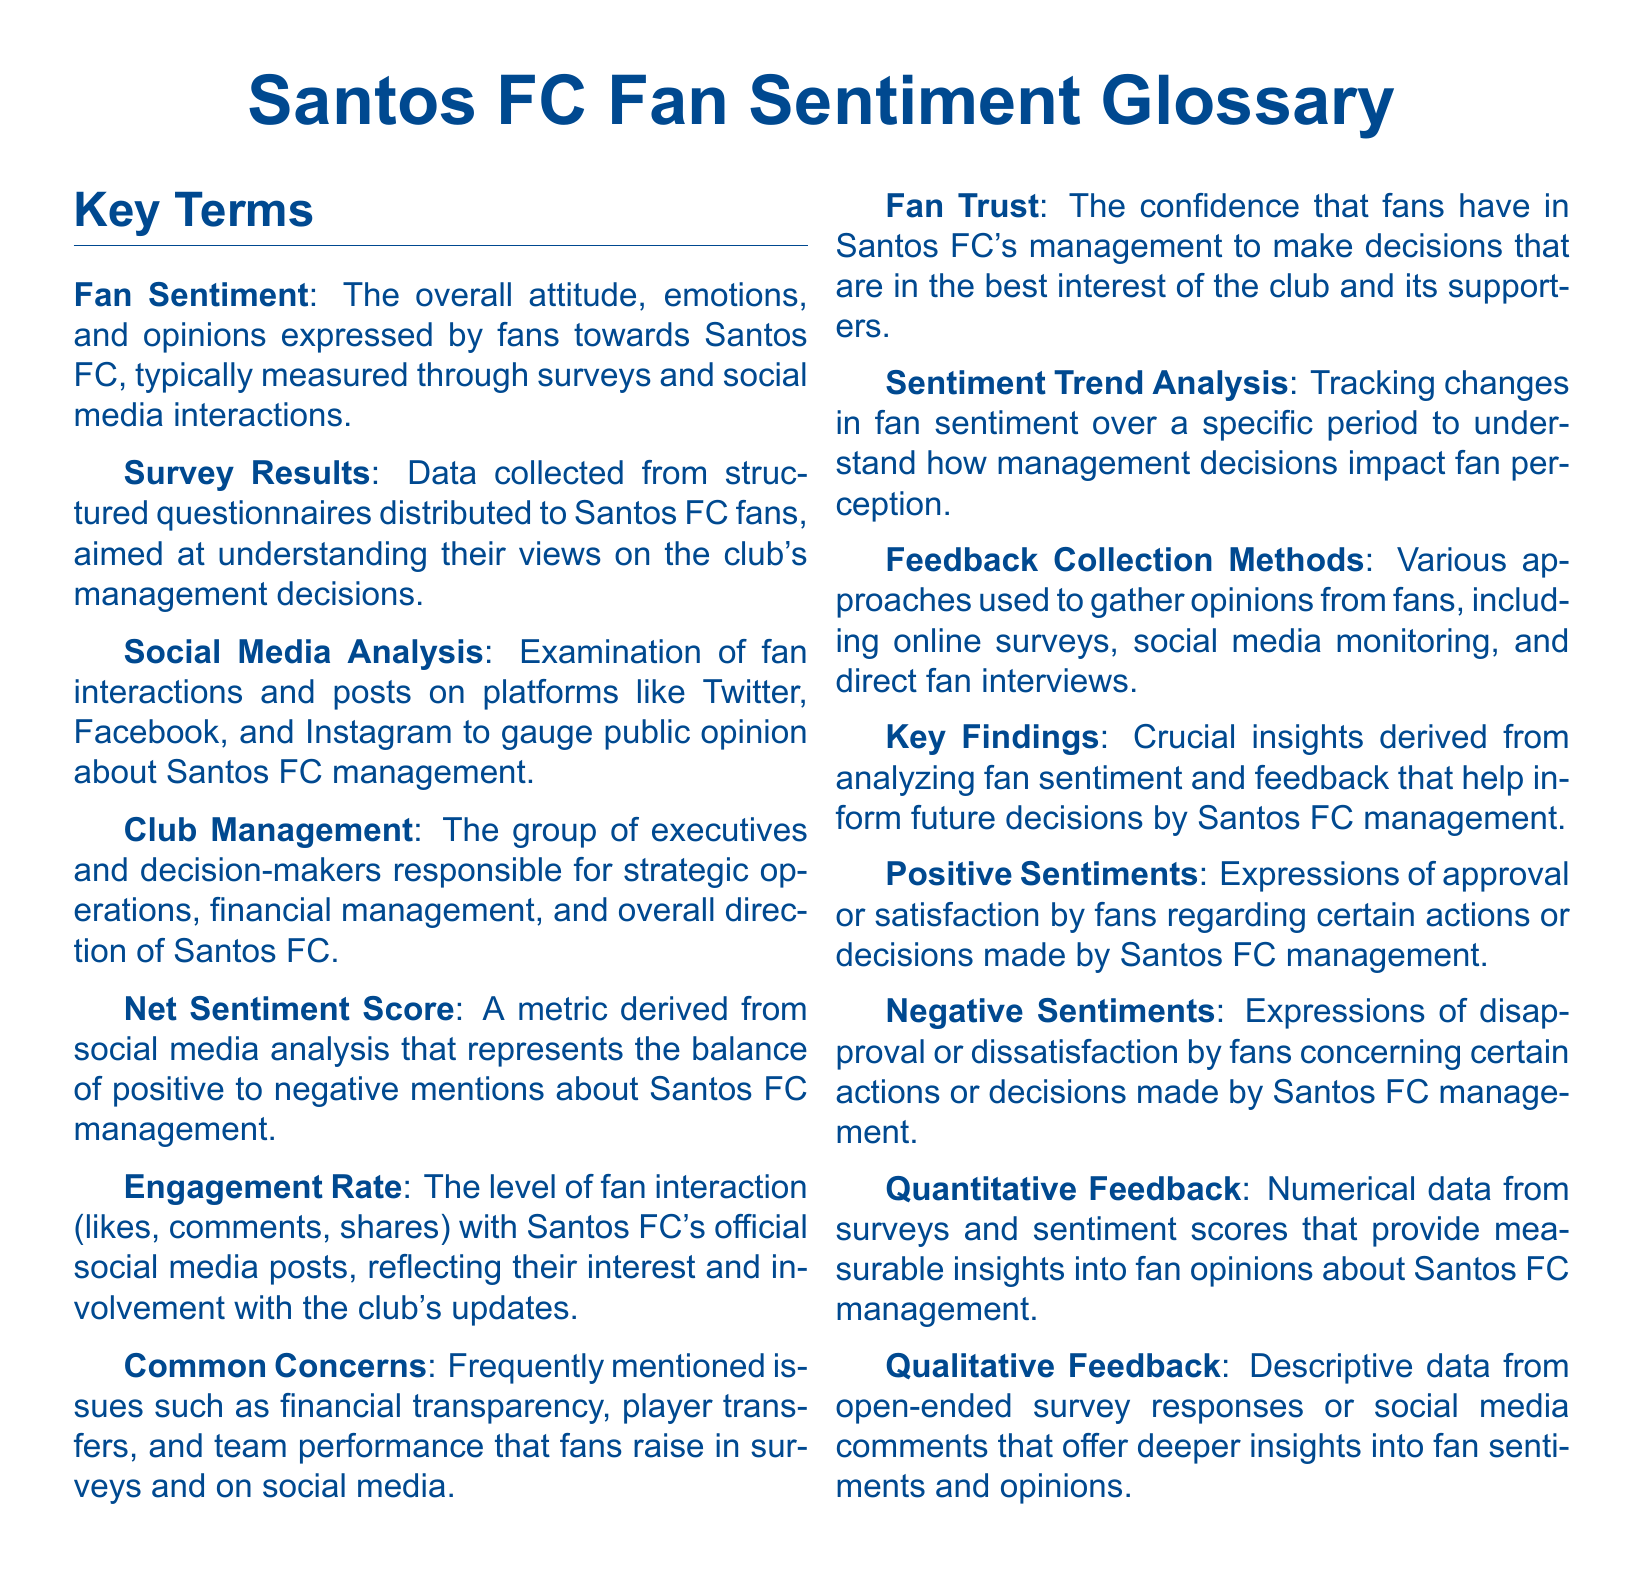what does fan sentiment mean? Fan sentiment refers to the overall attitude, emotions, and opinions expressed by fans towards Santos FC.
Answer: overall attitude, emotions, and opinions what is the engagement rate? The engagement rate is the level of fan interaction with Santos FC's official social media posts.
Answer: level of fan interaction what does the net sentiment score represent? The net sentiment score represents the balance of positive to negative mentions about Santos FC management.
Answer: balance of positive to negative mentions what are common concerns mentioned by fans? Common concerns are frequently mentioned issues such as financial transparency and team performance.
Answer: financial transparency, team performance what is the purpose of feedback collection methods? The purpose of feedback collection methods is to gather opinions from fans.
Answer: gather opinions from fans what type of feedback offers deeper insights into fan sentiments? Qualitative feedback offers deeper insights into fan sentiments and opinions.
Answer: Qualitative feedback how are survey results collected? Survey results are collected from structured questionnaires distributed to Santos FC fans.
Answer: structured questionnaires what is the definition of club management? Club management is the group of executives and decision-makers responsible for the strategic operations of Santos FC.
Answer: group of executives and decision-makers what does sentiment trend analysis track? Sentiment trend analysis tracks changes in fan sentiment over a specific period.
Answer: changes in fan sentiment 